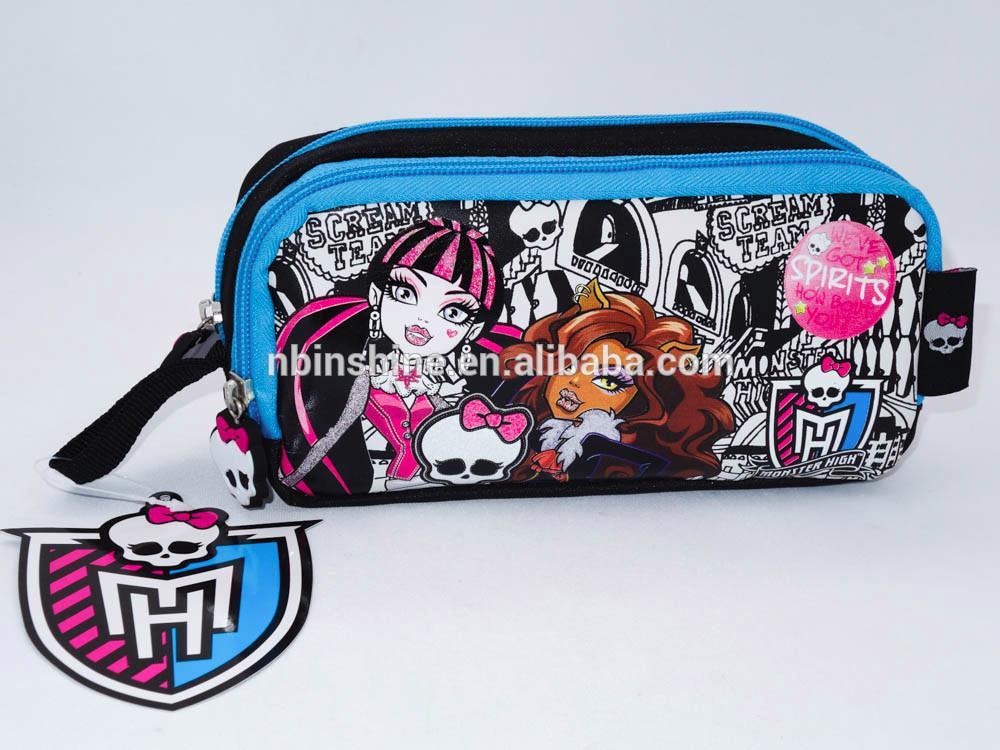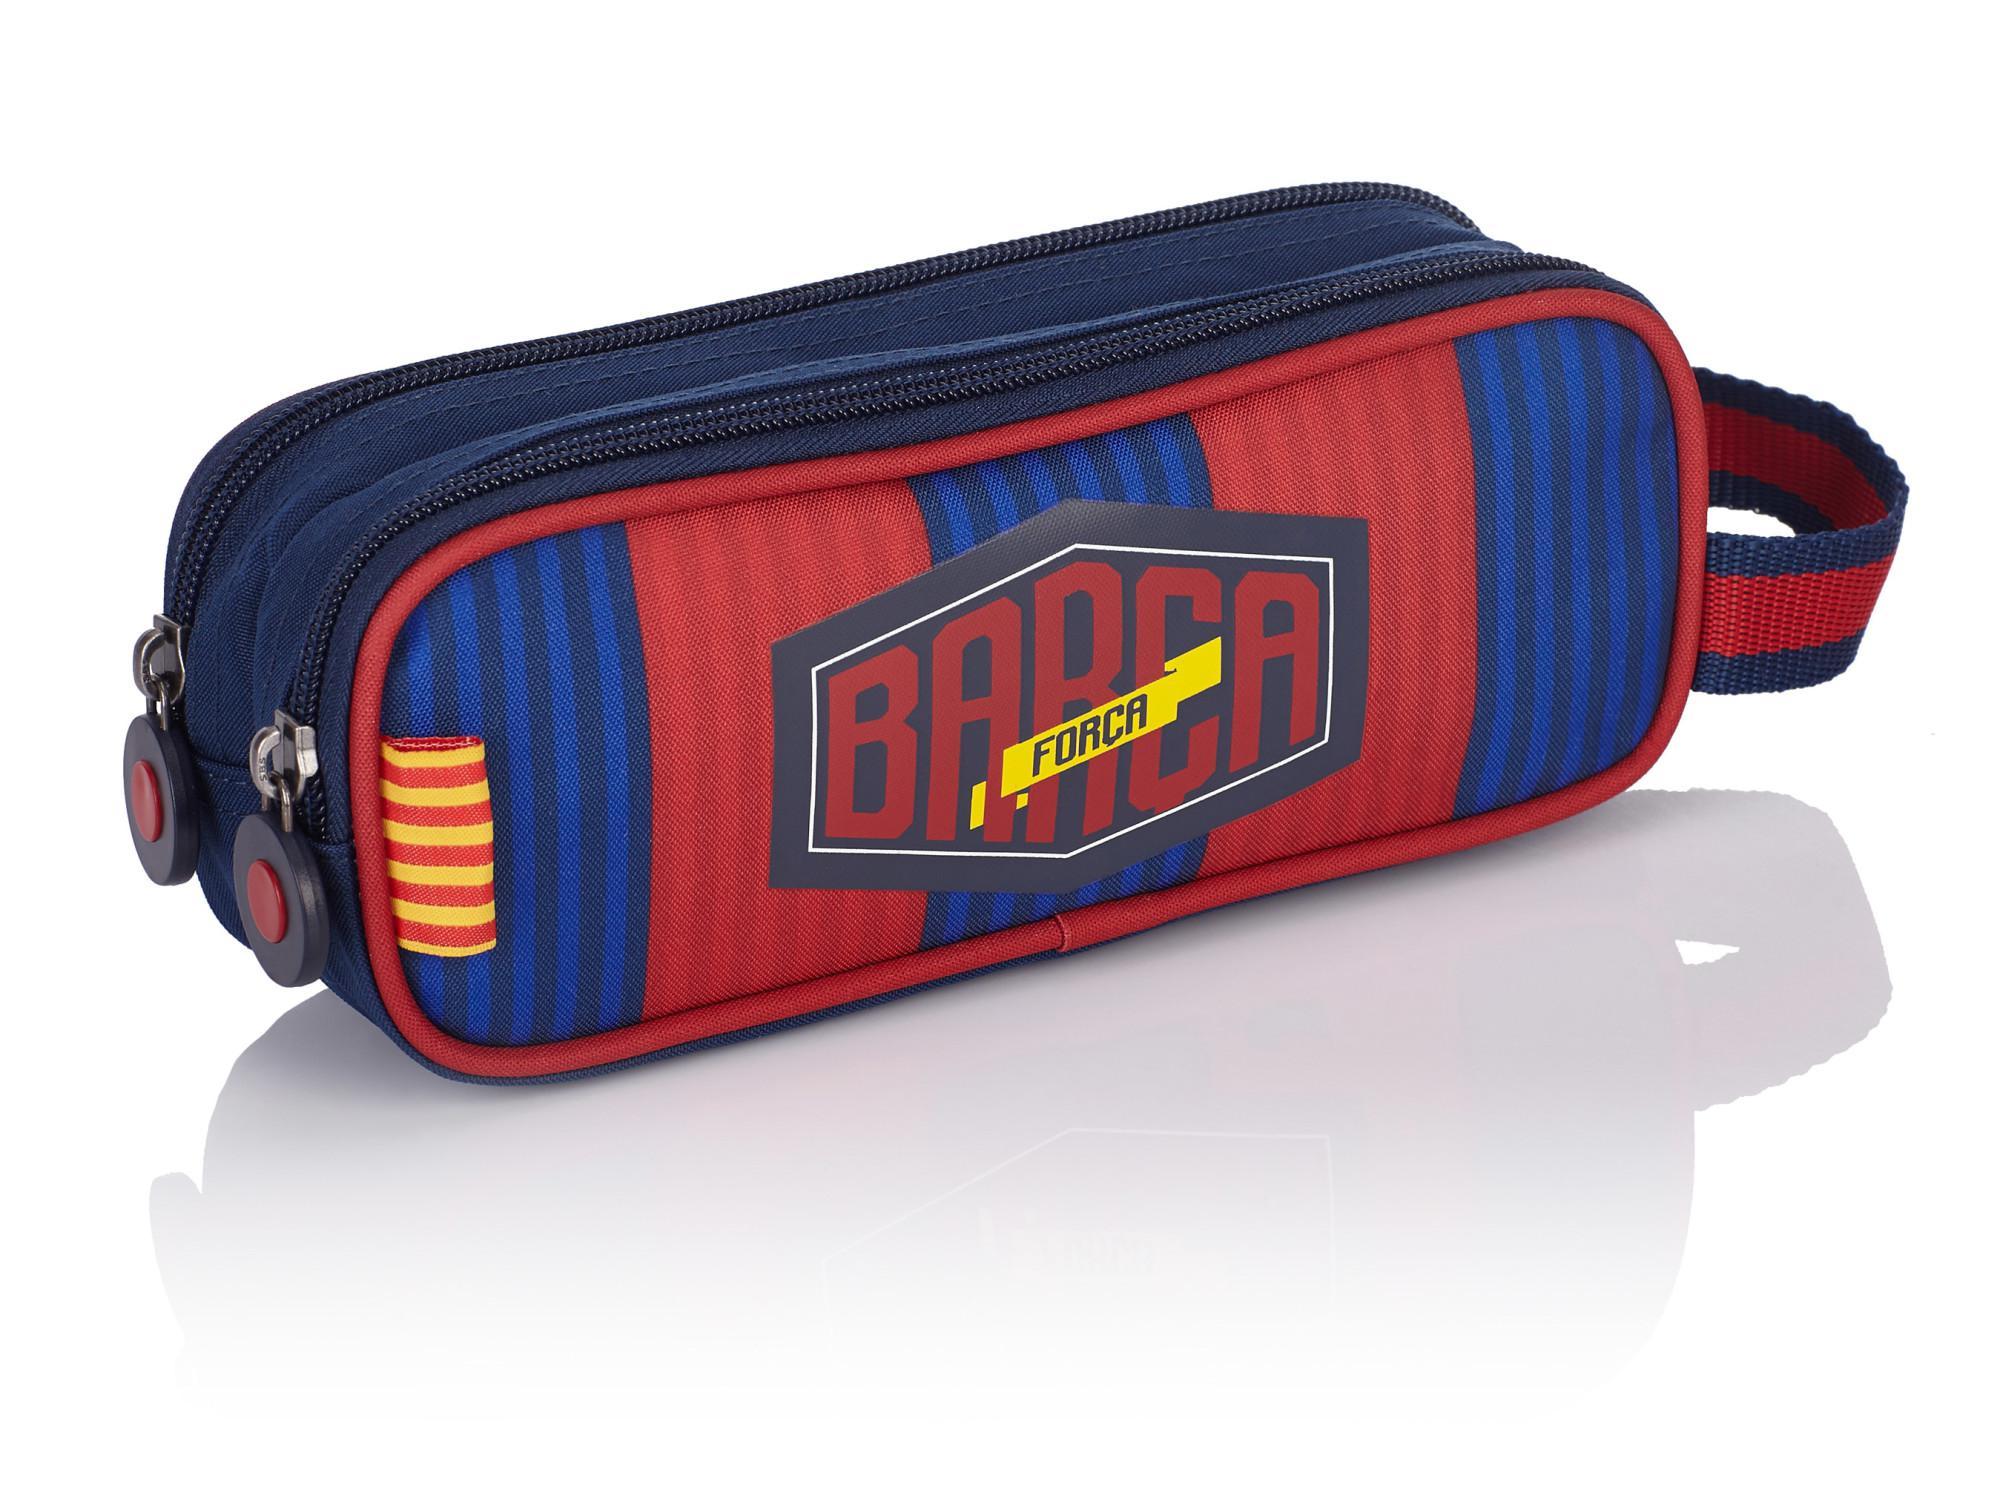The first image is the image on the left, the second image is the image on the right. Analyze the images presented: Is the assertion "in the image pair there are two oval shaped pencil pouches with cording on the outside" valid? Answer yes or no. No. The first image is the image on the left, the second image is the image on the right. For the images shown, is this caption "There is a Monster High pencil case." true? Answer yes or no. Yes. 